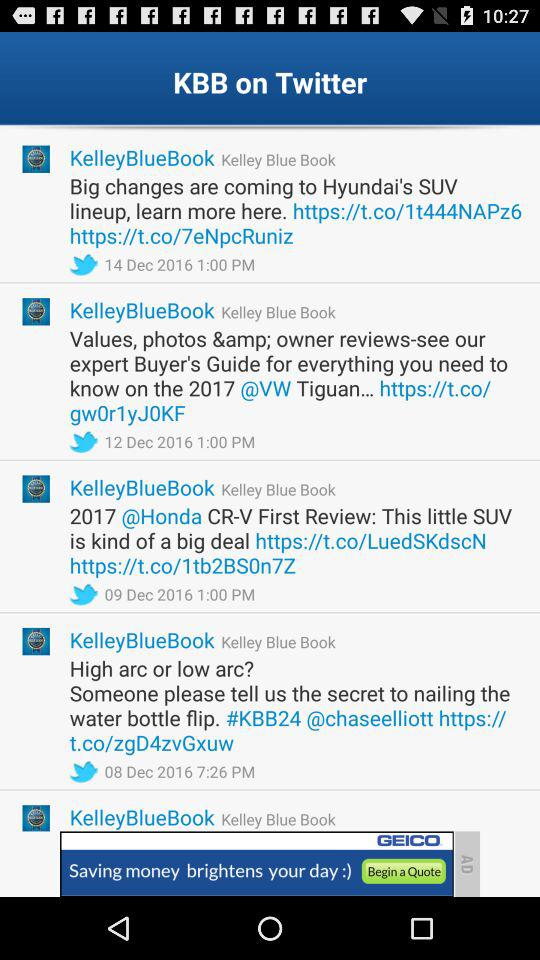What is the difference in price between the Fair Purchase Price and the Dealer Invoice?
Answer the question using a single word or phrase. $1631 